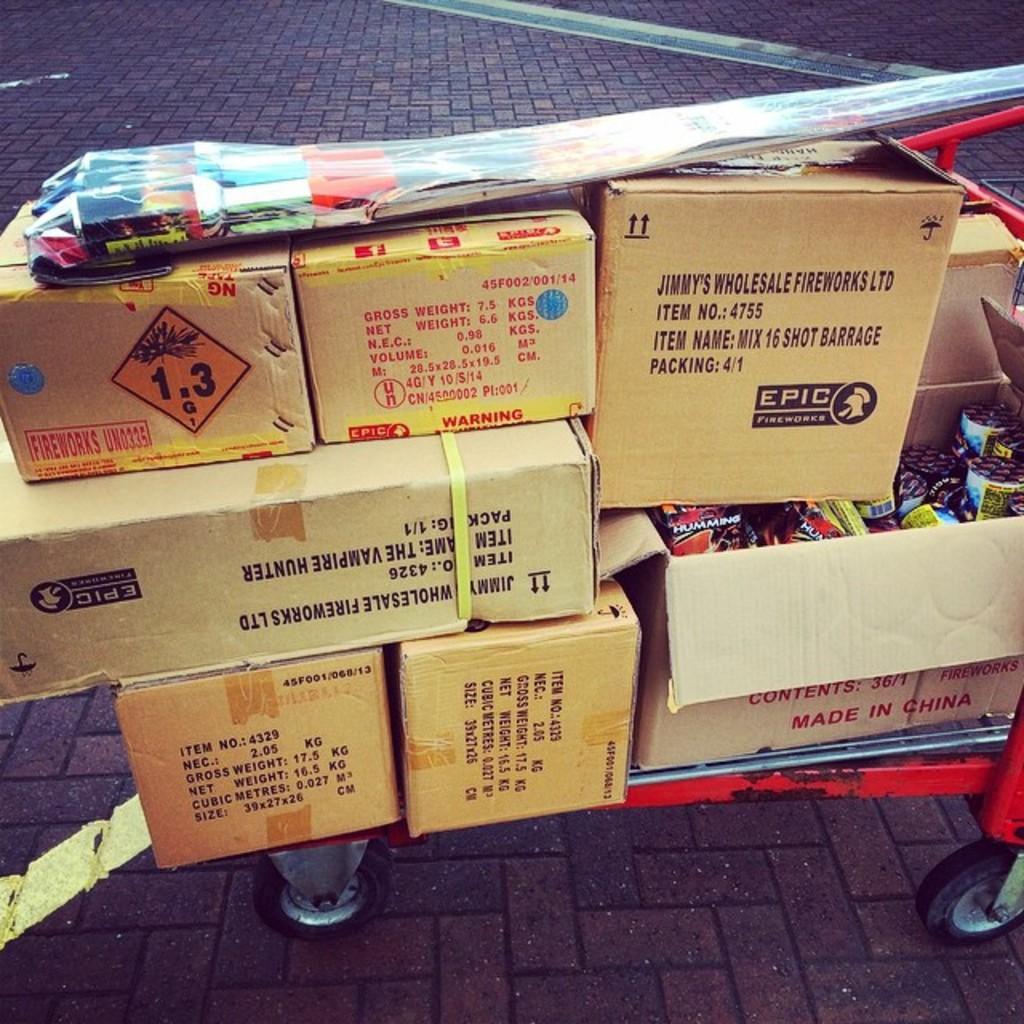Can you describe this image briefly? In this picture, we see a red color trolley containing the carton boxes. We see some text written on the boxes. These boxes contain some objects. On top of the boxes, we see a plastic bag. At the bottom, we see the pavement. In the background, we see the pavement and it is in black color. 